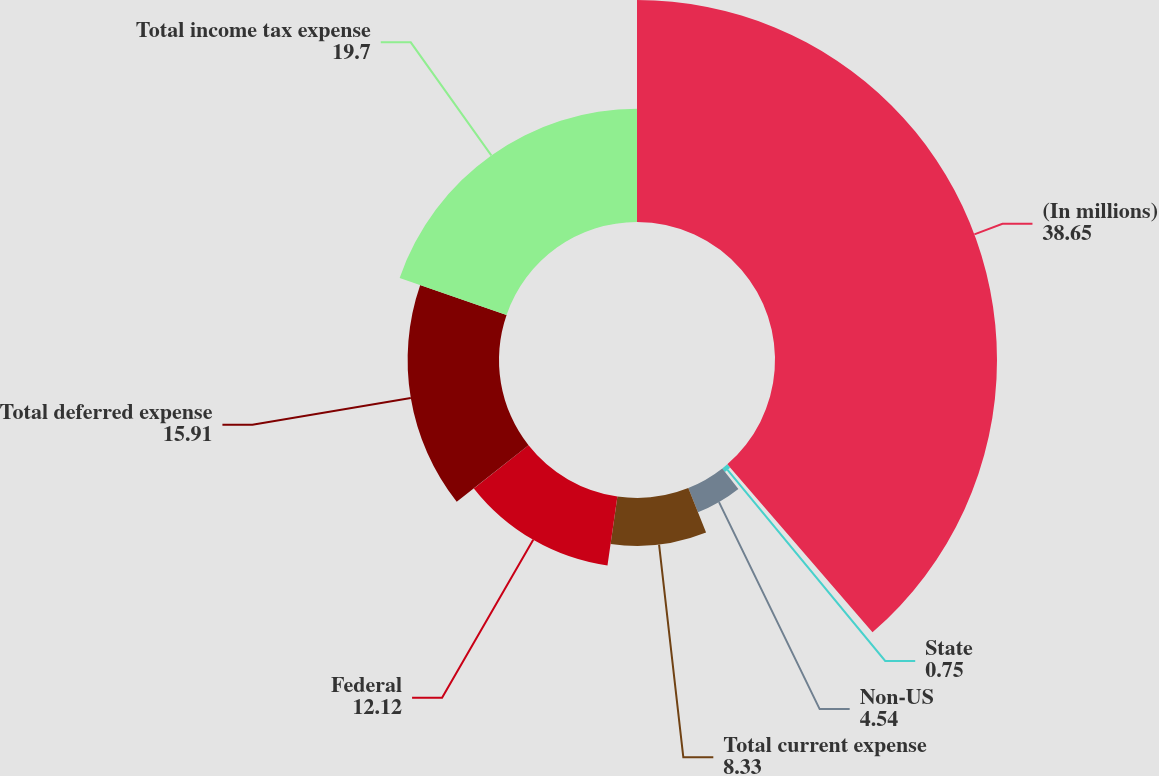Convert chart to OTSL. <chart><loc_0><loc_0><loc_500><loc_500><pie_chart><fcel>(In millions)<fcel>State<fcel>Non-US<fcel>Total current expense<fcel>Federal<fcel>Total deferred expense<fcel>Total income tax expense<nl><fcel>38.65%<fcel>0.75%<fcel>4.54%<fcel>8.33%<fcel>12.12%<fcel>15.91%<fcel>19.7%<nl></chart> 